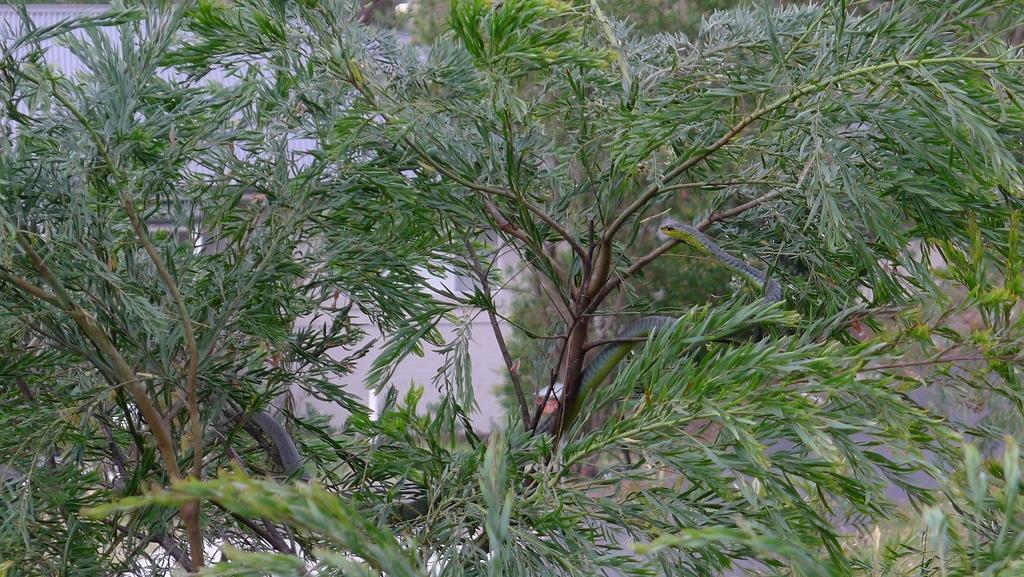Please provide a concise description of this image. In this picture we can see a snake on the tree. 